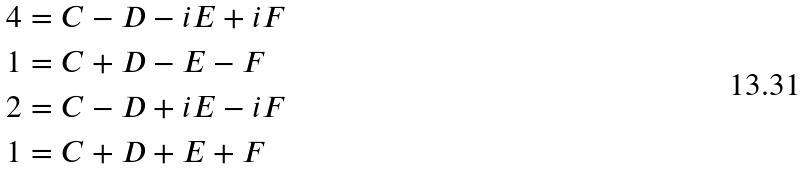<formula> <loc_0><loc_0><loc_500><loc_500>4 & = C - D - i E + i F \\ 1 & = C + D - E - F \\ 2 & = C - D + i E - i F \\ 1 & = C + D + E + F</formula> 